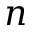<formula> <loc_0><loc_0><loc_500><loc_500>n</formula> 